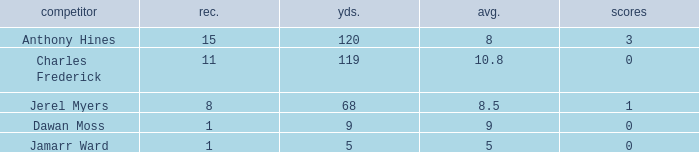I'm looking to parse the entire table for insights. Could you assist me with that? {'header': ['competitor', 'rec.', 'yds.', 'avg.', 'scores'], 'rows': [['Anthony Hines', '15', '120', '8', '3'], ['Charles Frederick', '11', '119', '10.8', '0'], ['Jerel Myers', '8', '68', '8.5', '1'], ['Dawan Moss', '1', '9', '9', '0'], ['Jamarr Ward', '1', '5', '5', '0']]} What is the average number of TDs when the yards are less than 119, the AVG is larger than 5, and Jamarr Ward is a player? None. 